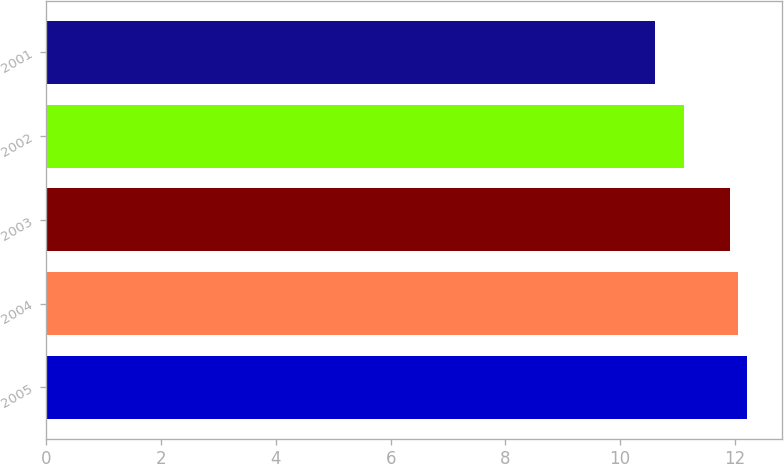Convert chart to OTSL. <chart><loc_0><loc_0><loc_500><loc_500><bar_chart><fcel>2005<fcel>2004<fcel>2003<fcel>2002<fcel>2001<nl><fcel>12.21<fcel>12.06<fcel>11.91<fcel>11.11<fcel>10.6<nl></chart> 